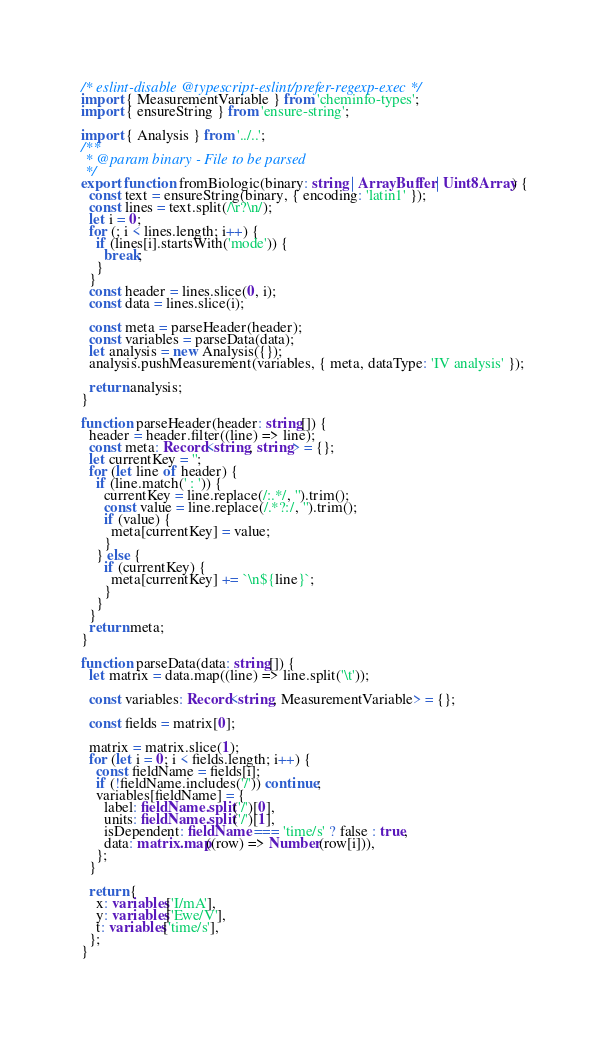<code> <loc_0><loc_0><loc_500><loc_500><_TypeScript_>/* eslint-disable @typescript-eslint/prefer-regexp-exec */
import { MeasurementVariable } from 'cheminfo-types';
import { ensureString } from 'ensure-string';

import { Analysis } from '../..';
/**
 * @param binary - File to be parsed
 */
export function fromBiologic(binary: string | ArrayBuffer | Uint8Array) {
  const text = ensureString(binary, { encoding: 'latin1' });
  const lines = text.split(/\r?\n/);
  let i = 0;
  for (; i < lines.length; i++) {
    if (lines[i].startsWith('mode')) {
      break;
    }
  }
  const header = lines.slice(0, i);
  const data = lines.slice(i);

  const meta = parseHeader(header);
  const variables = parseData(data);
  let analysis = new Analysis({});
  analysis.pushMeasurement(variables, { meta, dataType: 'IV analysis' });

  return analysis;
}

function parseHeader(header: string[]) {
  header = header.filter((line) => line);
  const meta: Record<string, string> = {};
  let currentKey = '';
  for (let line of header) {
    if (line.match(' : ')) {
      currentKey = line.replace(/:.*/, '').trim();
      const value = line.replace(/.*?:/, '').trim();
      if (value) {
        meta[currentKey] = value;
      }
    } else {
      if (currentKey) {
        meta[currentKey] += `\n${line}`;
      }
    }
  }
  return meta;
}

function parseData(data: string[]) {
  let matrix = data.map((line) => line.split('\t'));

  const variables: Record<string, MeasurementVariable> = {};

  const fields = matrix[0];

  matrix = matrix.slice(1);
  for (let i = 0; i < fields.length; i++) {
    const fieldName = fields[i];
    if (!fieldName.includes('/')) continue;
    variables[fieldName] = {
      label: fieldName.split('/')[0],
      units: fieldName.split('/')[1],
      isDependent: fieldName === 'time/s' ? false : true,
      data: matrix.map((row) => Number(row[i])),
    };
  }

  return {
    x: variables['I/mA'],
    y: variables['Ewe/V'],
    t: variables['time/s'],
  };
}
</code> 